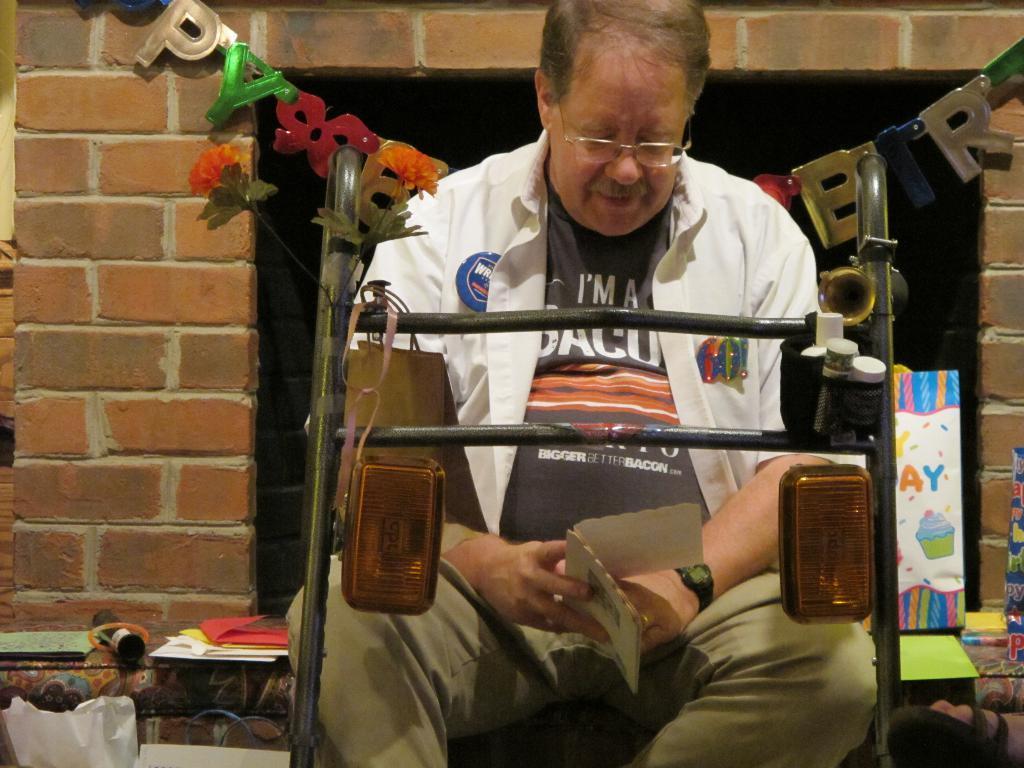Describe this image in one or two sentences. In the picture we can see a man sitting on the bench, front of him we can see a stand with some lights and in the background, we can see a wall with brick design and beside him on the bench we can see some greeting cards. 